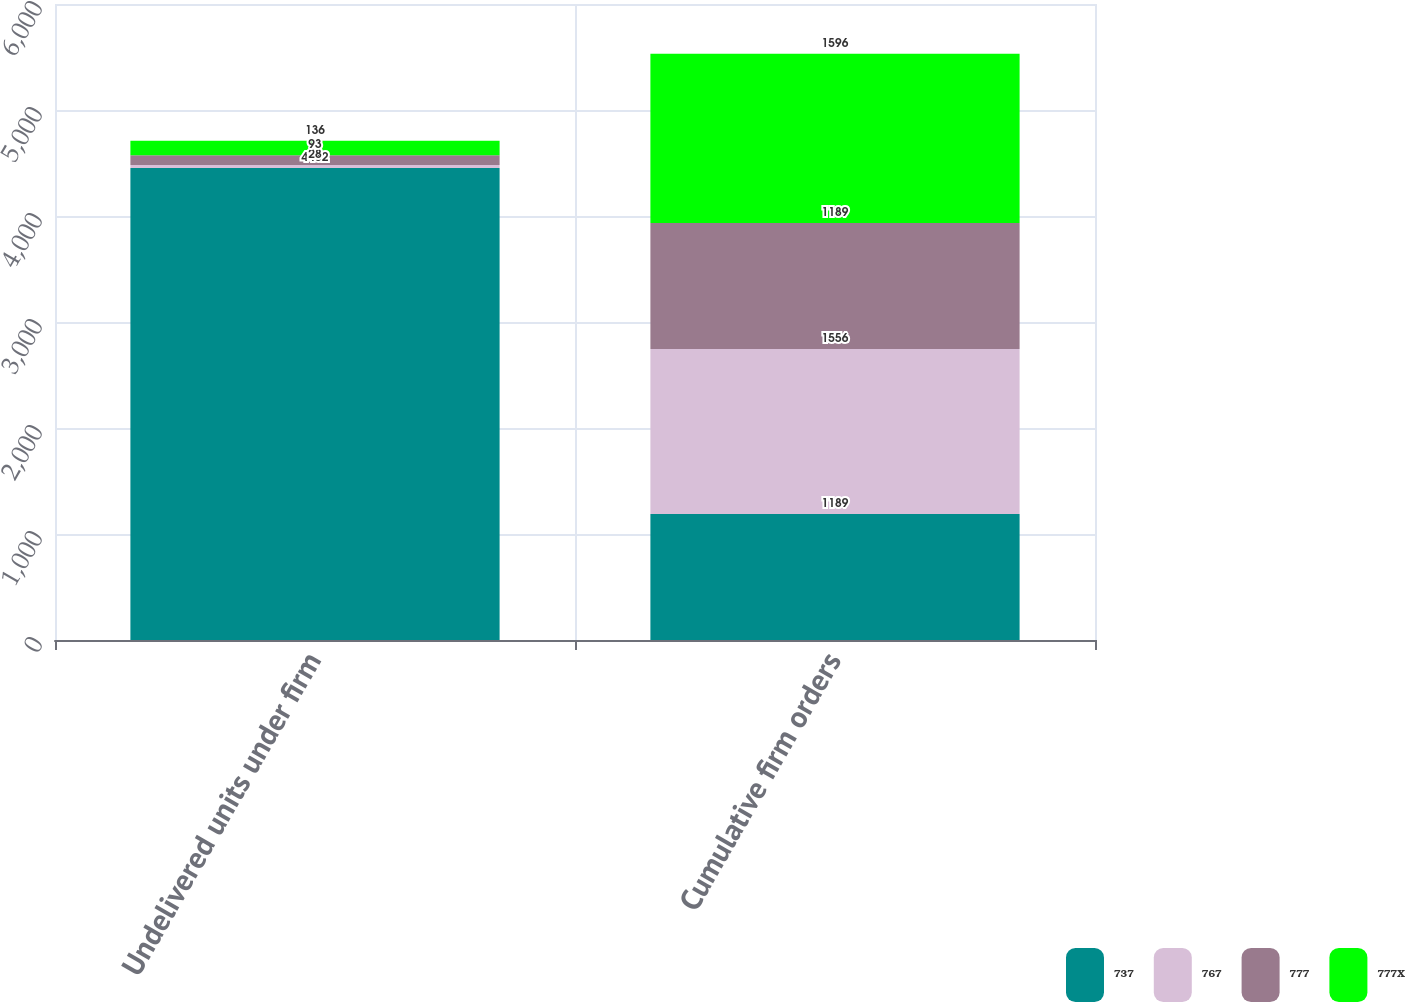<chart> <loc_0><loc_0><loc_500><loc_500><stacked_bar_chart><ecel><fcel>Undelivered units under firm<fcel>Cumulative firm orders<nl><fcel>737<fcel>4452<fcel>1189<nl><fcel>767<fcel>28<fcel>1556<nl><fcel>777<fcel>93<fcel>1189<nl><fcel>777X<fcel>136<fcel>1596<nl></chart> 